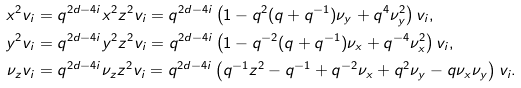Convert formula to latex. <formula><loc_0><loc_0><loc_500><loc_500>x ^ { 2 } v _ { i } & = q ^ { 2 d - 4 i } x ^ { 2 } z ^ { 2 } v _ { i } = q ^ { 2 d - 4 i } \left ( 1 - q ^ { 2 } ( q + q ^ { - 1 } ) \nu _ { y } + q ^ { 4 } \nu _ { y } ^ { 2 } \right ) v _ { i } , \\ y ^ { 2 } v _ { i } & = q ^ { 2 d - 4 i } y ^ { 2 } z ^ { 2 } v _ { i } = q ^ { 2 d - 4 i } \left ( 1 - q ^ { - 2 } ( q + q ^ { - 1 } ) \nu _ { x } + q ^ { - 4 } \nu _ { x } ^ { 2 } \right ) v _ { i } , \\ \nu _ { z } v _ { i } & = q ^ { 2 d - 4 i } \nu _ { z } z ^ { 2 } v _ { i } = q ^ { 2 d - 4 i } \left ( q ^ { - 1 } z ^ { 2 } - q ^ { - 1 } + q ^ { - 2 } \nu _ { x } + q ^ { 2 } \nu _ { y } - q \nu _ { x } \nu _ { y } \right ) v _ { i } .</formula> 